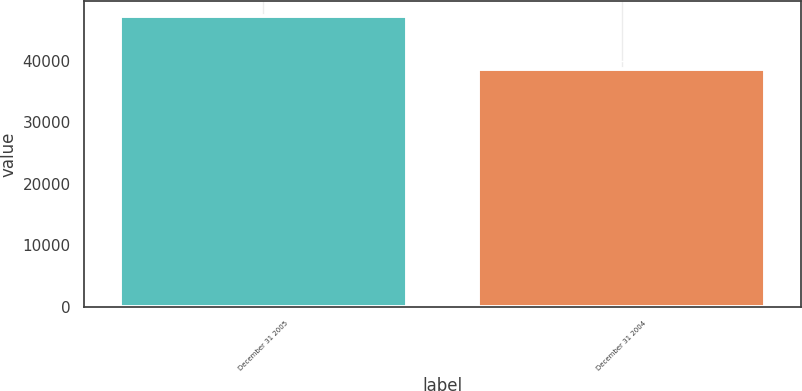<chart> <loc_0><loc_0><loc_500><loc_500><bar_chart><fcel>December 31 2005<fcel>December 31 2004<nl><fcel>47359<fcel>38609<nl></chart> 